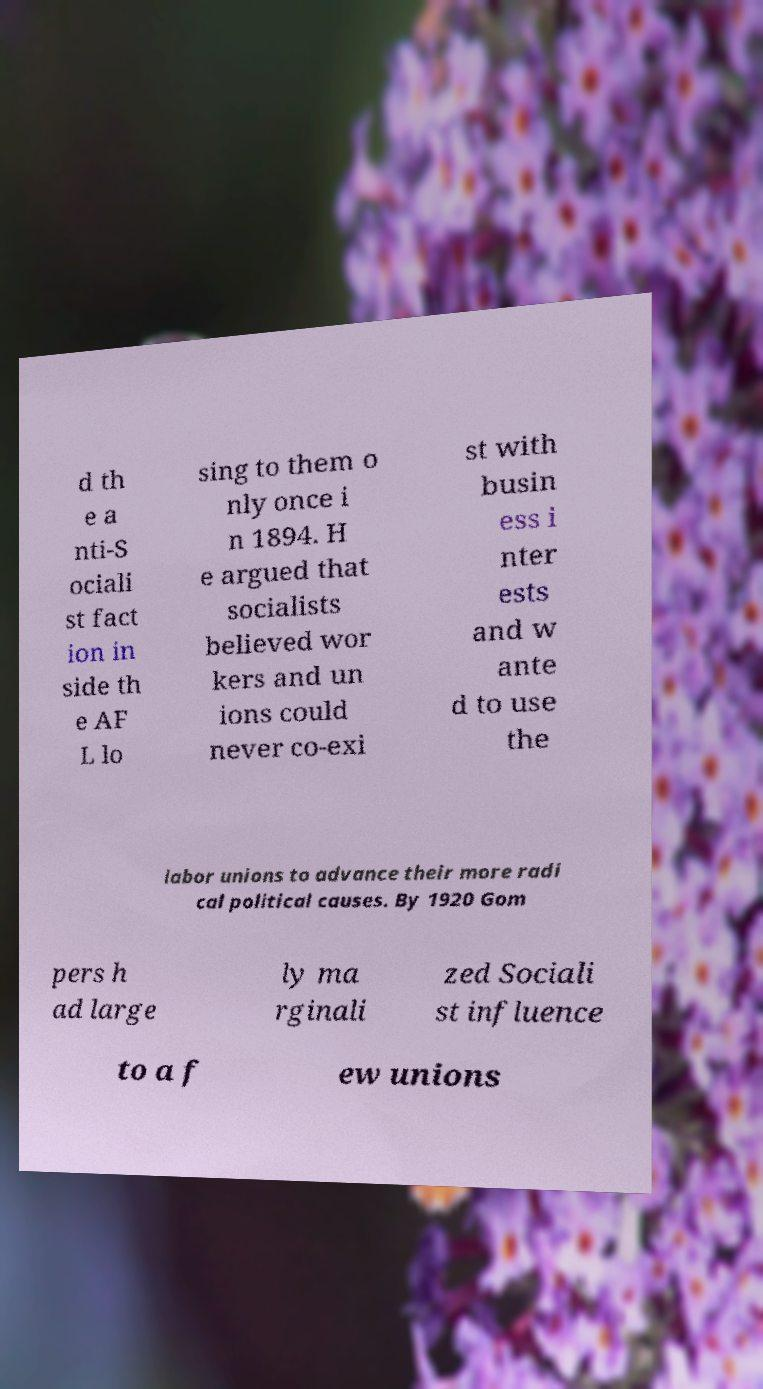Could you assist in decoding the text presented in this image and type it out clearly? d th e a nti-S ociali st fact ion in side th e AF L lo sing to them o nly once i n 1894. H e argued that socialists believed wor kers and un ions could never co-exi st with busin ess i nter ests and w ante d to use the labor unions to advance their more radi cal political causes. By 1920 Gom pers h ad large ly ma rginali zed Sociali st influence to a f ew unions 